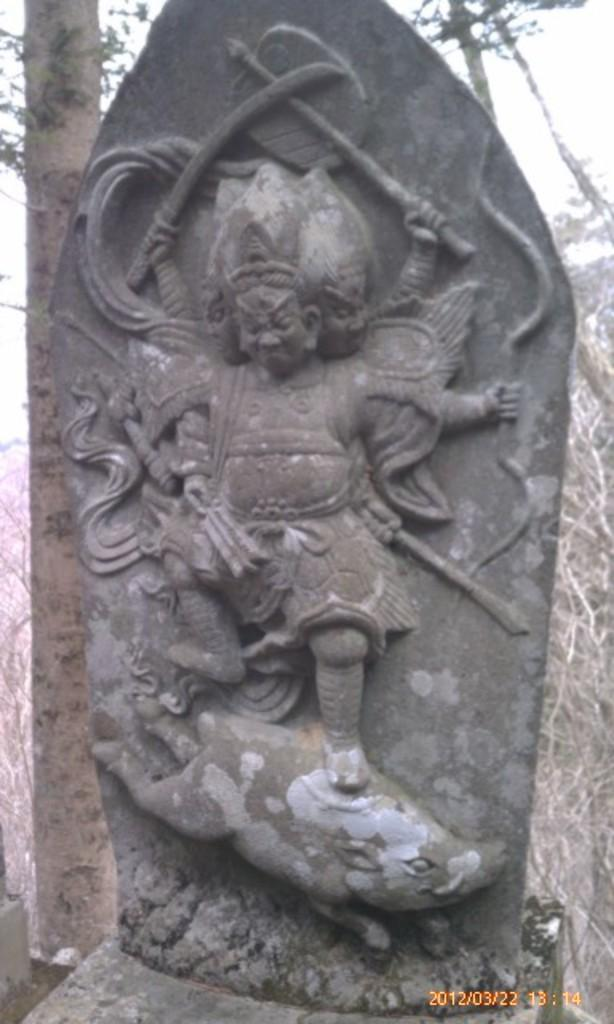What is the main subject of the picture? The main subject of the picture is a rock carving. What can be seen in the background of the picture? There are trees in the background of the picture. What type of cloud can be seen in the picture? There is no cloud present in the picture; it features a rock carving and trees in the background. What kind of blade is being used to carve the rock in the picture? There is no blade or carving activity visible in the picture; it only shows a rock carving and trees in the background. 